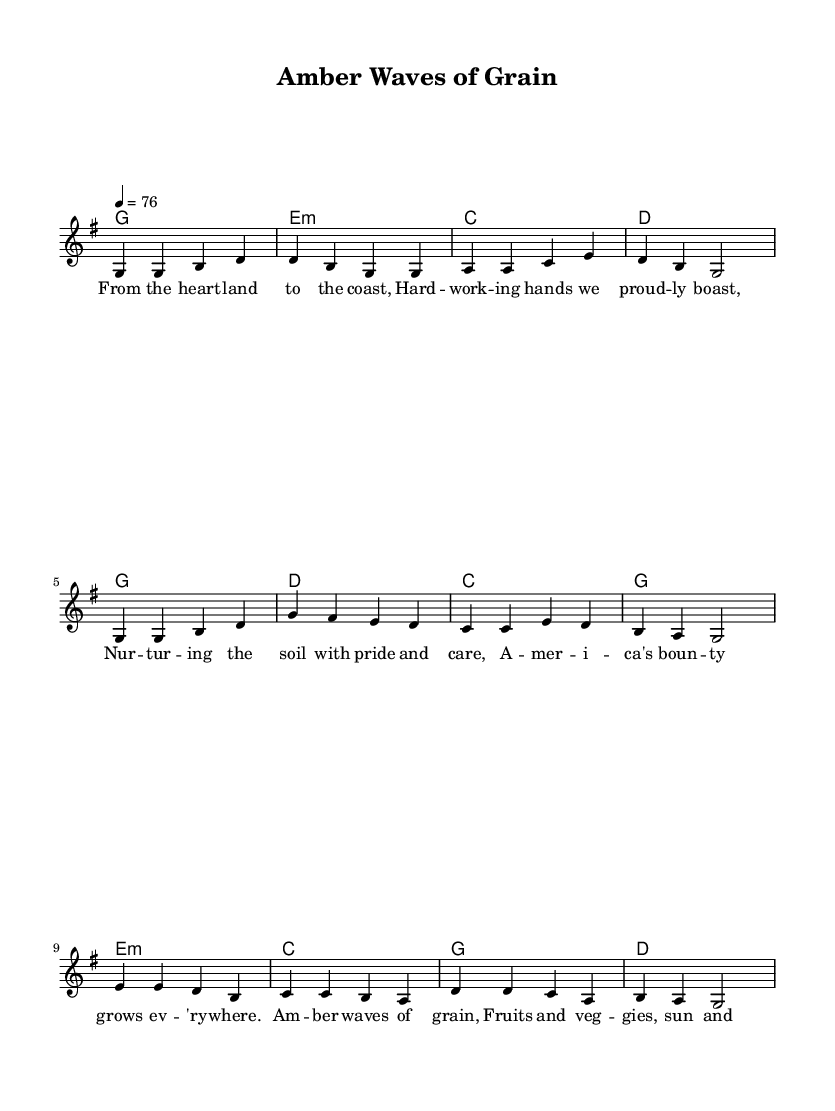What is the key signature of this music? The key signature is determined by the absence or presence of sharps and flats in the score. The sheet music shows no accidentals, indicating that it is set in G major, which has one sharp (F#). However, because only the notes and not the full key signature are represented, the context of G major is assumed.
Answer: G major What is the time signature of this music? The time signature is found at the beginning of the score, represented through a set of numbers. In this sheet music, the time signature is displayed as 4/4, meaning there are four beats per measure.
Answer: 4/4 What is the tempo marking for this piece? The tempo marking is shown in the sheet music and is expressed as a metronome marking. This score indicates a metronome marking of 76 beats per minute, which guides the speed of the music.
Answer: 76 How many verses are there in the song? By reviewing the structure of the lyrics in the provided data, only one verse ("verseOne") is included in the score, leading to the conclusion that there is one verse present in this sheet music.
Answer: One What is the main theme expressed in the lyrics? The lyrics characterized by agricultural references and pride in farming suggest a celebration of American agriculture, specifically focusing on the beauty and importance of crops like grain and other produce, illustrating a patriotic connection to the land.
Answer: American agriculture In what part of the song does the chord change to E minor? The chord change to E minor occurs in the bridge section of the song, as indicated by the harmonies, which shows that the E minor chord is used immediately at the beginning of the bridge.
Answer: Bridge 